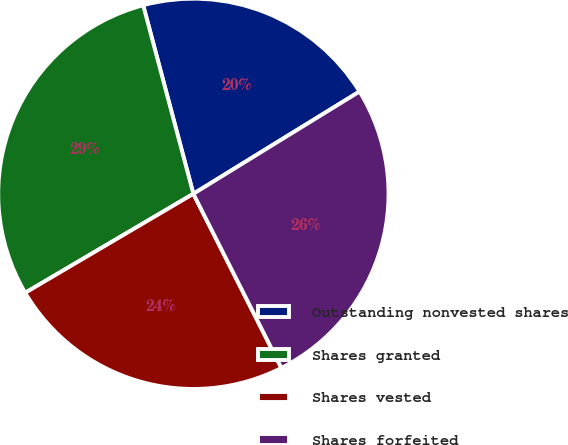Convert chart. <chart><loc_0><loc_0><loc_500><loc_500><pie_chart><fcel>Outstanding nonvested shares<fcel>Shares granted<fcel>Shares vested<fcel>Shares forfeited<nl><fcel>20.36%<fcel>29.33%<fcel>23.98%<fcel>26.34%<nl></chart> 